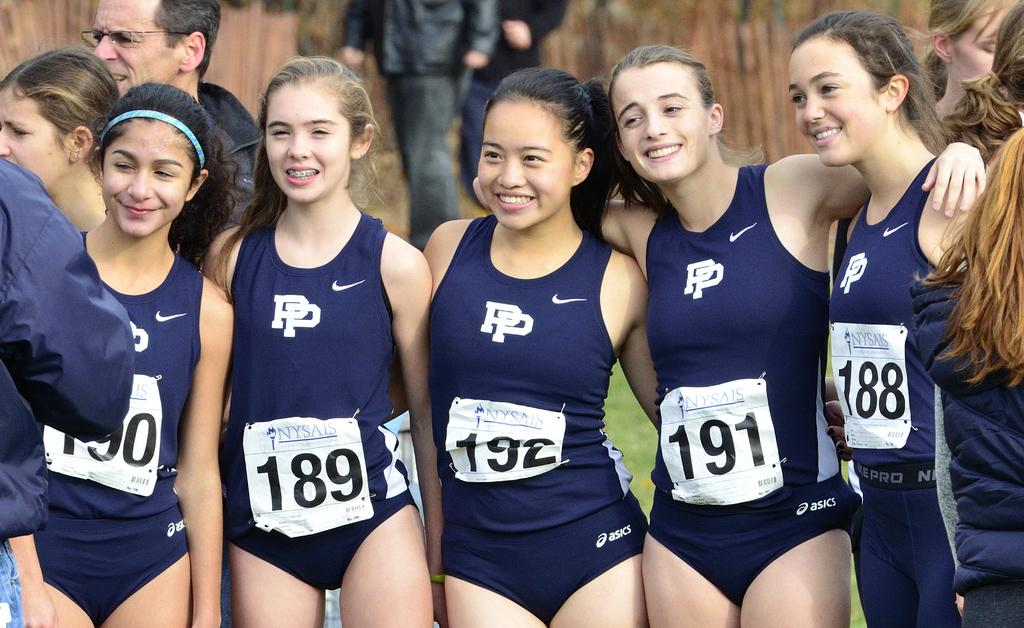Provide a one-sentence caption for the provided image. Swimmer 191 has her arms around swimmers 192 and 188. 